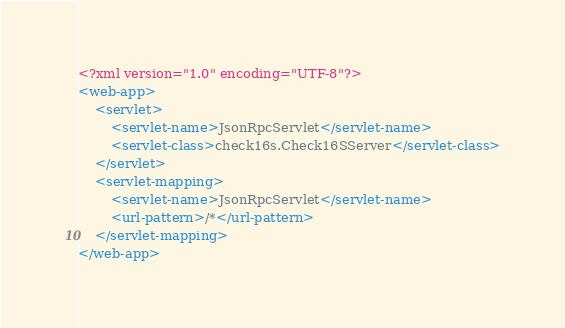Convert code to text. <code><loc_0><loc_0><loc_500><loc_500><_XML_><?xml version="1.0" encoding="UTF-8"?>
<web-app>
    <servlet>
        <servlet-name>JsonRpcServlet</servlet-name>
        <servlet-class>check16s.Check16SServer</servlet-class>
    </servlet>
    <servlet-mapping>
        <servlet-name>JsonRpcServlet</servlet-name>
        <url-pattern>/*</url-pattern>
    </servlet-mapping>
</web-app>

</code> 